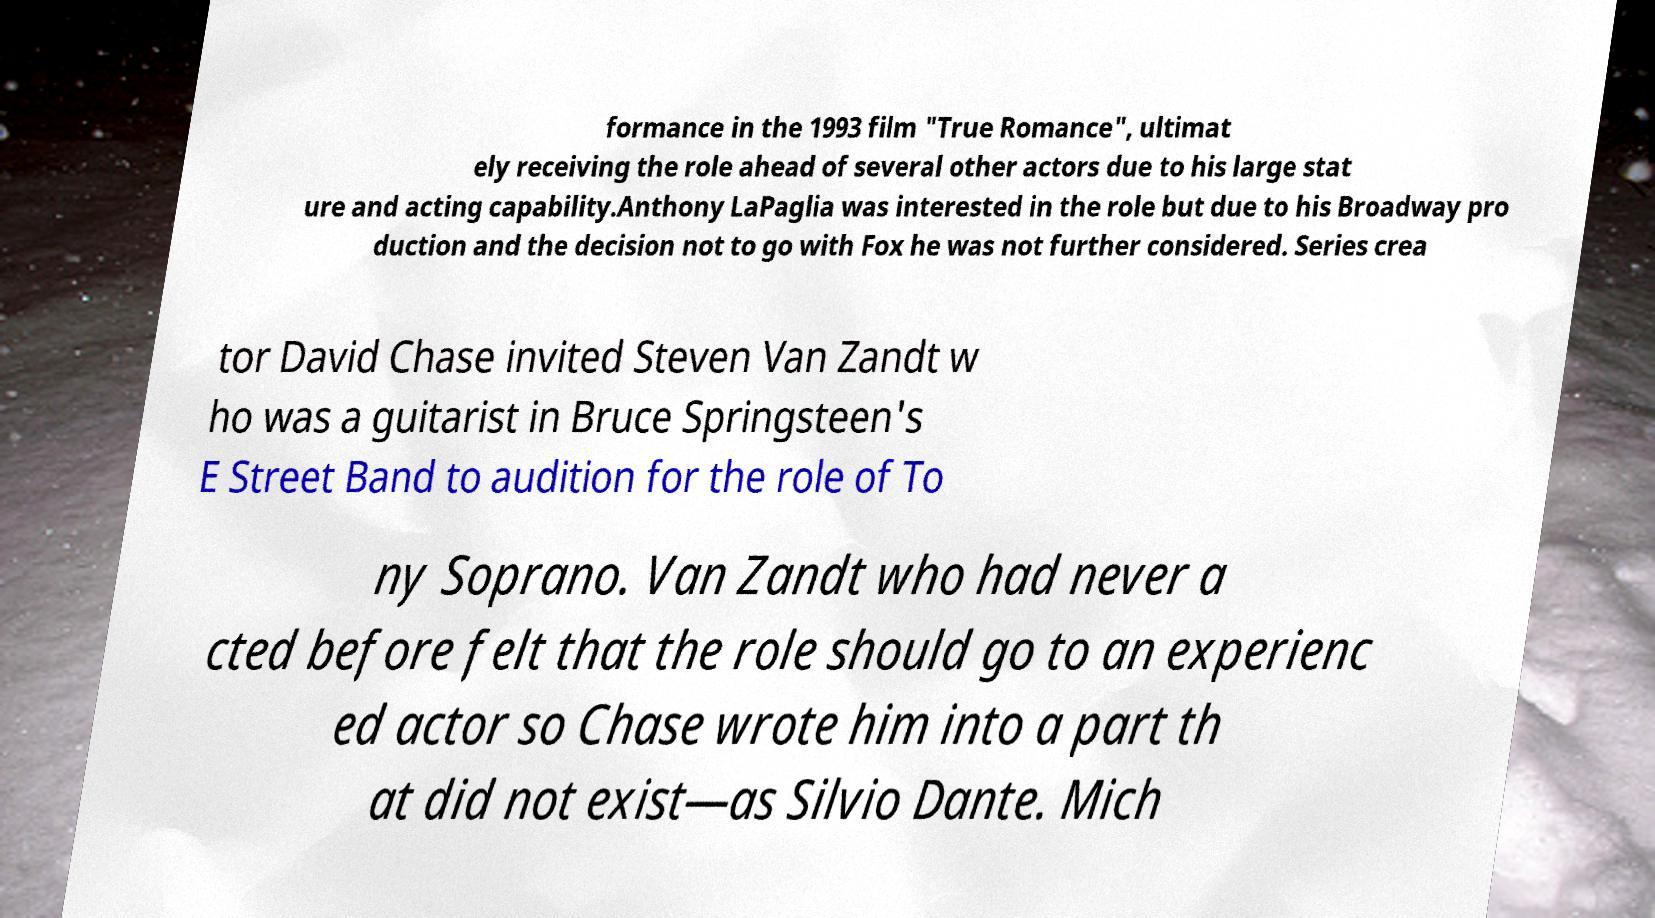What messages or text are displayed in this image? I need them in a readable, typed format. formance in the 1993 film "True Romance", ultimat ely receiving the role ahead of several other actors due to his large stat ure and acting capability.Anthony LaPaglia was interested in the role but due to his Broadway pro duction and the decision not to go with Fox he was not further considered. Series crea tor David Chase invited Steven Van Zandt w ho was a guitarist in Bruce Springsteen's E Street Band to audition for the role of To ny Soprano. Van Zandt who had never a cted before felt that the role should go to an experienc ed actor so Chase wrote him into a part th at did not exist—as Silvio Dante. Mich 